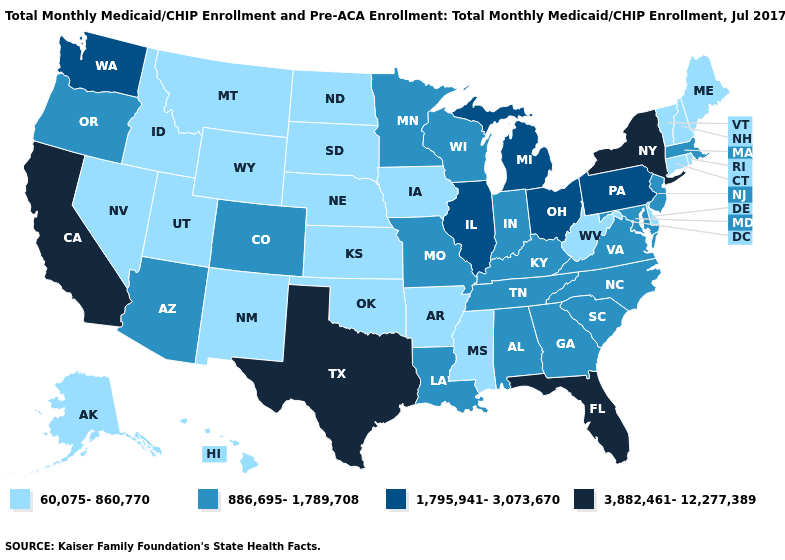What is the lowest value in states that border Illinois?
Write a very short answer. 60,075-860,770. Among the states that border Utah , which have the highest value?
Keep it brief. Arizona, Colorado. What is the lowest value in the USA?
Concise answer only. 60,075-860,770. What is the value of Florida?
Short answer required. 3,882,461-12,277,389. What is the lowest value in states that border Pennsylvania?
Give a very brief answer. 60,075-860,770. Among the states that border Delaware , which have the highest value?
Keep it brief. Pennsylvania. What is the lowest value in the USA?
Short answer required. 60,075-860,770. Name the states that have a value in the range 886,695-1,789,708?
Quick response, please. Alabama, Arizona, Colorado, Georgia, Indiana, Kentucky, Louisiana, Maryland, Massachusetts, Minnesota, Missouri, New Jersey, North Carolina, Oregon, South Carolina, Tennessee, Virginia, Wisconsin. Name the states that have a value in the range 1,795,941-3,073,670?
Give a very brief answer. Illinois, Michigan, Ohio, Pennsylvania, Washington. Among the states that border Washington , does Idaho have the highest value?
Quick response, please. No. Does Maryland have the lowest value in the South?
Answer briefly. No. What is the value of New Jersey?
Write a very short answer. 886,695-1,789,708. What is the lowest value in the USA?
Be succinct. 60,075-860,770. What is the lowest value in the Northeast?
Answer briefly. 60,075-860,770. Among the states that border New York , does Connecticut have the lowest value?
Quick response, please. Yes. 